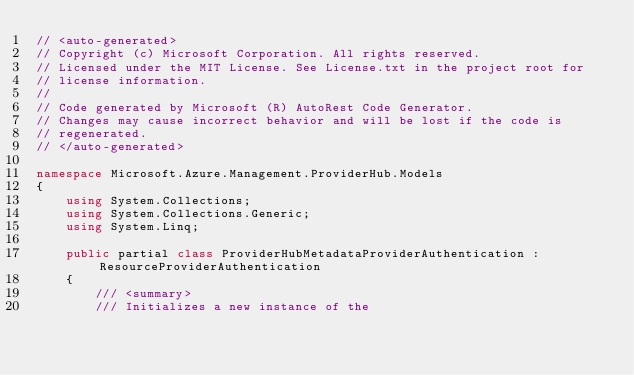<code> <loc_0><loc_0><loc_500><loc_500><_C#_>// <auto-generated>
// Copyright (c) Microsoft Corporation. All rights reserved.
// Licensed under the MIT License. See License.txt in the project root for
// license information.
//
// Code generated by Microsoft (R) AutoRest Code Generator.
// Changes may cause incorrect behavior and will be lost if the code is
// regenerated.
// </auto-generated>

namespace Microsoft.Azure.Management.ProviderHub.Models
{
    using System.Collections;
    using System.Collections.Generic;
    using System.Linq;

    public partial class ProviderHubMetadataProviderAuthentication : ResourceProviderAuthentication
    {
        /// <summary>
        /// Initializes a new instance of the</code> 